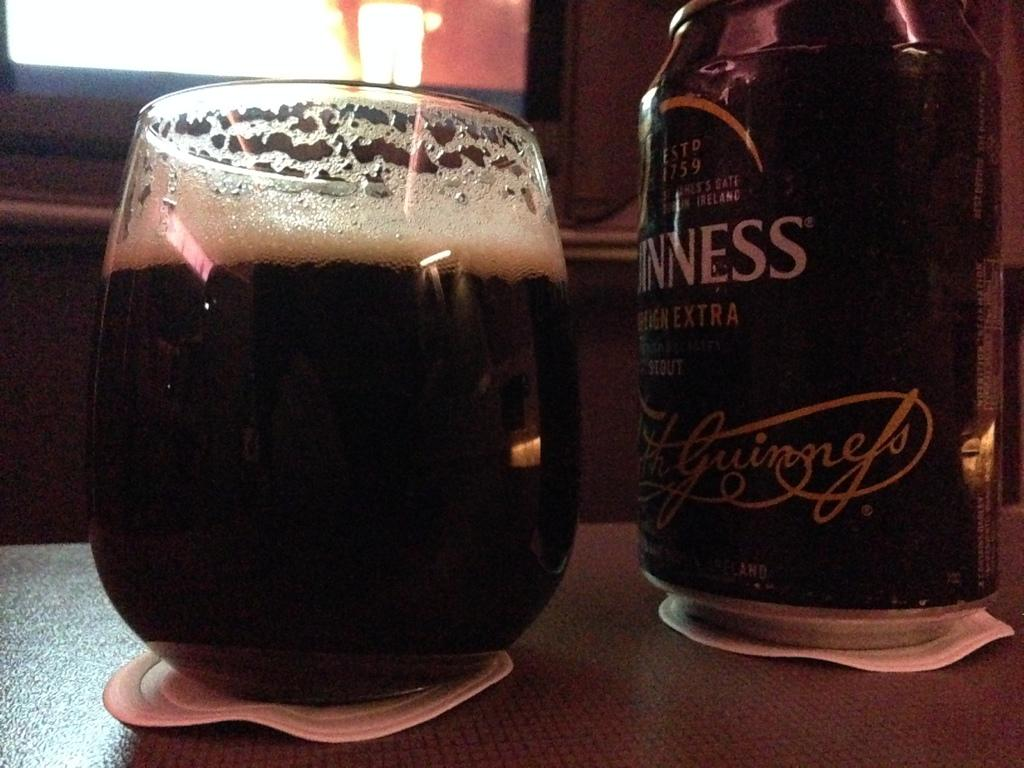<image>
Give a short and clear explanation of the subsequent image. A glass filled with Guinness sits on a wooden table. 